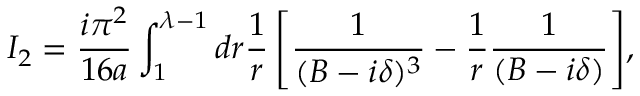<formula> <loc_0><loc_0><loc_500><loc_500>I _ { 2 } = { \frac { i \pi ^ { 2 } } { 1 6 a } } \int _ { 1 } ^ { \lambda - 1 } { d r { \frac { 1 } { r } } \left [ { \frac { 1 } { ( B - i \delta ) ^ { 3 } } } - { \frac { 1 } { r } } { \frac { 1 } { ( B - i \delta ) } } \right ] } ,</formula> 